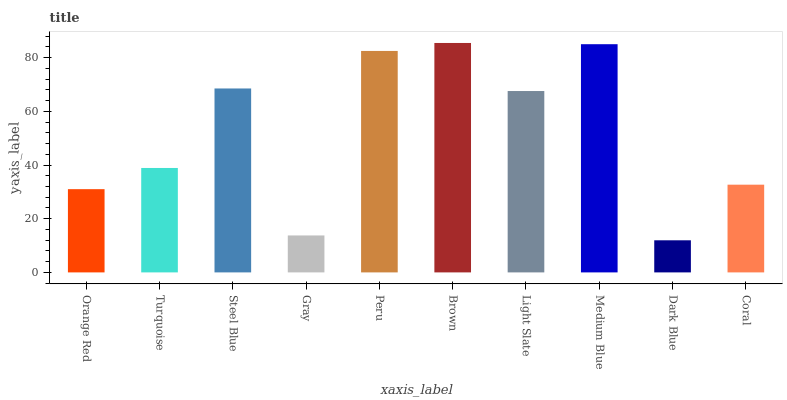Is Turquoise the minimum?
Answer yes or no. No. Is Turquoise the maximum?
Answer yes or no. No. Is Turquoise greater than Orange Red?
Answer yes or no. Yes. Is Orange Red less than Turquoise?
Answer yes or no. Yes. Is Orange Red greater than Turquoise?
Answer yes or no. No. Is Turquoise less than Orange Red?
Answer yes or no. No. Is Light Slate the high median?
Answer yes or no. Yes. Is Turquoise the low median?
Answer yes or no. Yes. Is Coral the high median?
Answer yes or no. No. Is Peru the low median?
Answer yes or no. No. 